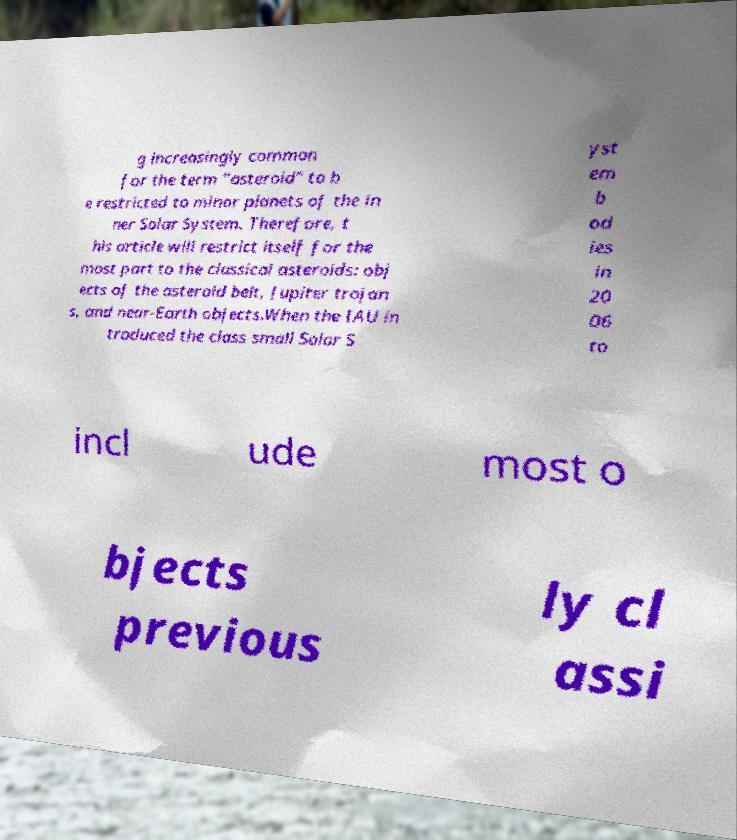Can you accurately transcribe the text from the provided image for me? g increasingly common for the term "asteroid" to b e restricted to minor planets of the in ner Solar System. Therefore, t his article will restrict itself for the most part to the classical asteroids: obj ects of the asteroid belt, Jupiter trojan s, and near-Earth objects.When the IAU in troduced the class small Solar S yst em b od ies in 20 06 to incl ude most o bjects previous ly cl assi 